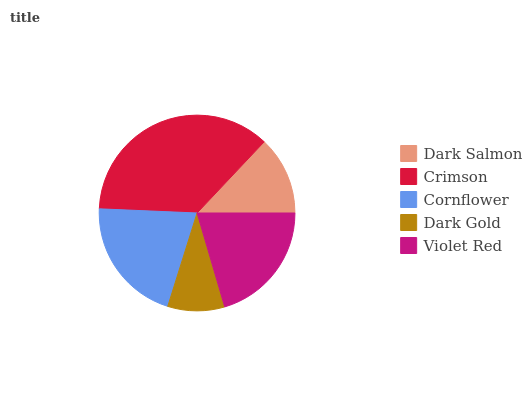Is Dark Gold the minimum?
Answer yes or no. Yes. Is Crimson the maximum?
Answer yes or no. Yes. Is Cornflower the minimum?
Answer yes or no. No. Is Cornflower the maximum?
Answer yes or no. No. Is Crimson greater than Cornflower?
Answer yes or no. Yes. Is Cornflower less than Crimson?
Answer yes or no. Yes. Is Cornflower greater than Crimson?
Answer yes or no. No. Is Crimson less than Cornflower?
Answer yes or no. No. Is Violet Red the high median?
Answer yes or no. Yes. Is Violet Red the low median?
Answer yes or no. Yes. Is Dark Gold the high median?
Answer yes or no. No. Is Dark Salmon the low median?
Answer yes or no. No. 